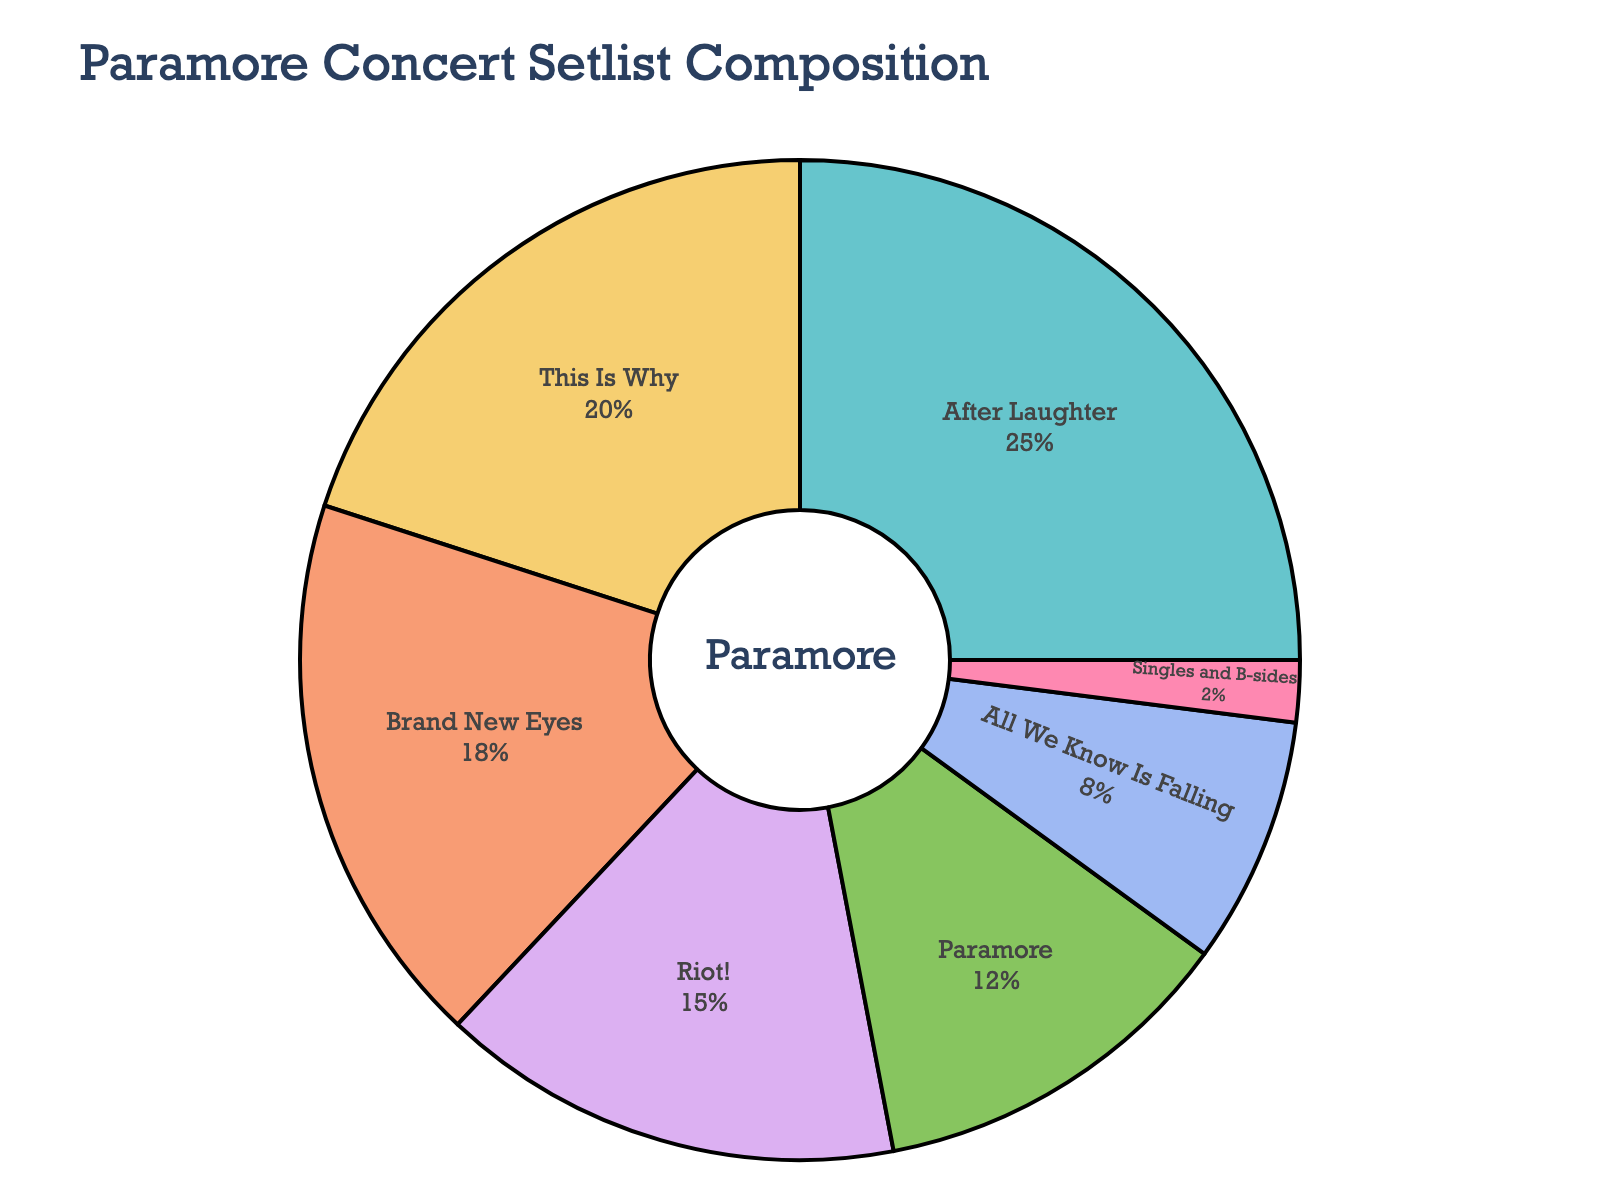Which album has the highest percentage of songs in the setlist? The figure shows the percentage of songs from various Paramore albums in the setlist. The album with the highest percentage is labeled and occupies the largest segment.
Answer: After Laughter How much more percentage of the setlist does 'After Laughter' have compared to 'This Is Why'? Subtract the percentage of 'This Is Why' from 'After Laughter'. So, 25% (After Laughter) - 20% (This Is Why) = 5%.
Answer: 5% Which album contributes the least number of songs to the setlist? The figure displays each album's contribution as a percentage. The album with the smallest percentage contributes the least number of songs.
Answer: Singles and B-sides What is the cumulative percentage of songs from 'Riot!', 'Paramore', and 'All We Know Is Falling'? Add the percentages of 'Riot!', 'Paramore', and 'All We Know Is Falling'. Hence, 15% (Riot!) + 12% (Paramore) + 8% (All We Know Is Falling) = 35%.
Answer: 35% Are the songs from 'Brand New Eyes' more dominant in the setlist than those from 'Paramore'? Compare the percentages of songs from 'Brand New Eyes' and 'Paramore'. 'Brand New Eyes' has 18% while 'Paramore' has 12%.
Answer: Yes Which two albums together make up a total of 45% of the setlist? Check for two albums whose percentages sum up to 45%. 'After Laughter' (25%) + 'Brand New Eyes' (18%) = 43% and so on. 'After Laughter' (25%) + 'This Is Why' (20%) = 45%.
Answer: After Laughter and This Is Why How many albums have a percentage contribution greater than 15% in the setlist? Identify and count the segments with percentages above 15%. These are 'After Laughter' (25%), 'This Is Why' (20%), and 'Brand New Eyes' (18%).
Answer: 3 What's the difference in percentage contribution between 'Riot!' and 'All We Know Is Falling'? Subtract the percentage of 'All We Know Is Falling' from 'Riot!'. So, 15% (Riot!) - 8% (All We Know Is Falling) = 7%.
Answer: 7% Which two closest albums in percentage contribution sum to 32%? Identify pairs of adjacent albums in percentage values. 'Paramore' (12%) + 'All We Know Is Falling' (8%) = 20%, then 'This Is Why' (20%) + 'Brand New Eyes' (18%) = 38%, and so on. The closest pair is 'Brand New Eyes' (18%) + 'Riot!' (15%) = 33%. However, 'Paramore' (12%) + 'Riot!' (15%) = 27%. Thus 'This Is Why' (20%) + 'All We Know Is Falling' (8%) = 28%.
Answer: There's no exact pair summing to 32%, closest ones sum to 33% or 30% 